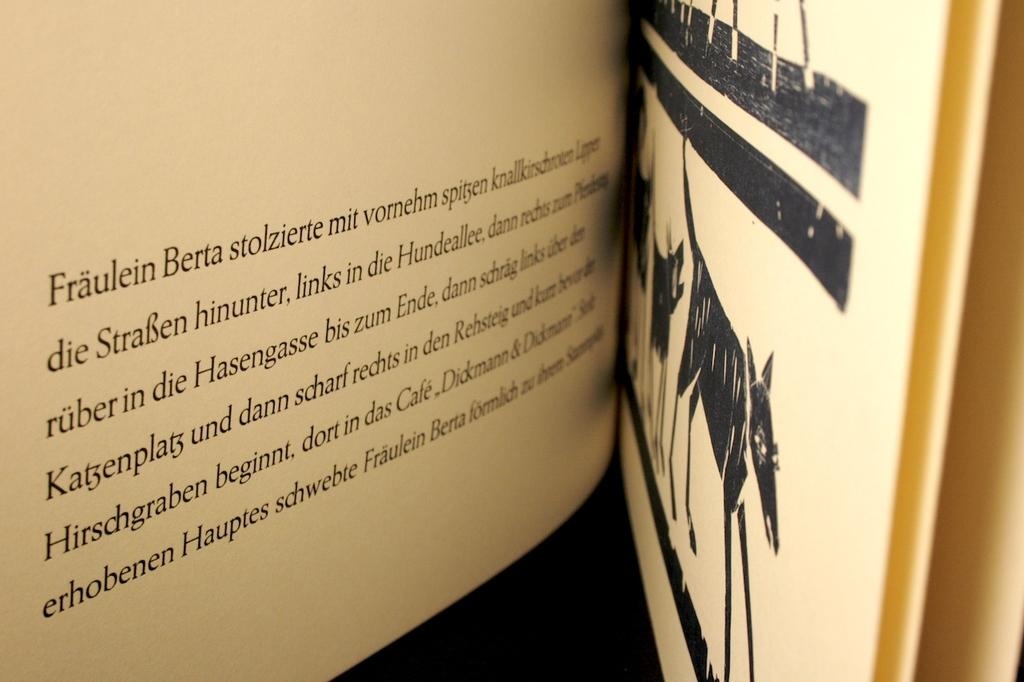<image>
Present a compact description of the photo's key features. A open tan book with black images written in German. 